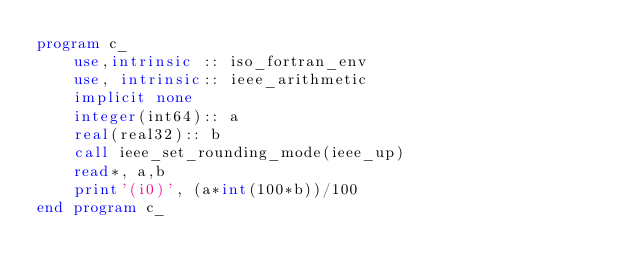Convert code to text. <code><loc_0><loc_0><loc_500><loc_500><_FORTRAN_>program c_
    use,intrinsic :: iso_fortran_env
    use, intrinsic:: ieee_arithmetic
    implicit none
    integer(int64):: a
    real(real32):: b
    call ieee_set_rounding_mode(ieee_up)
    read*, a,b
    print'(i0)', (a*int(100*b))/100
end program c_</code> 